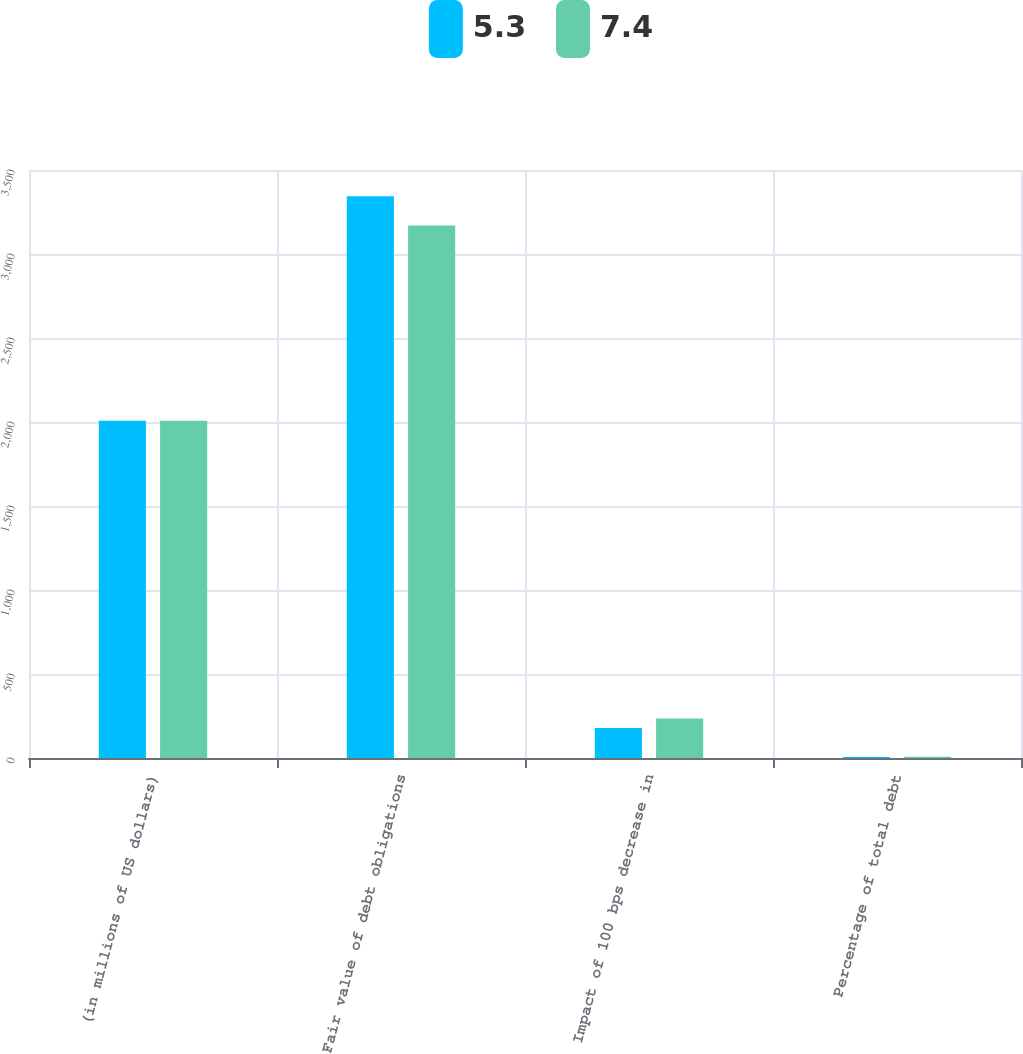<chart> <loc_0><loc_0><loc_500><loc_500><stacked_bar_chart><ecel><fcel>(in millions of US dollars)<fcel>Fair value of debt obligations<fcel>Impact of 100 bps decrease in<fcel>Percentage of total debt<nl><fcel>5.3<fcel>2008<fcel>3344<fcel>179<fcel>5.3<nl><fcel>7.4<fcel>2007<fcel>3169<fcel>235<fcel>7.4<nl></chart> 